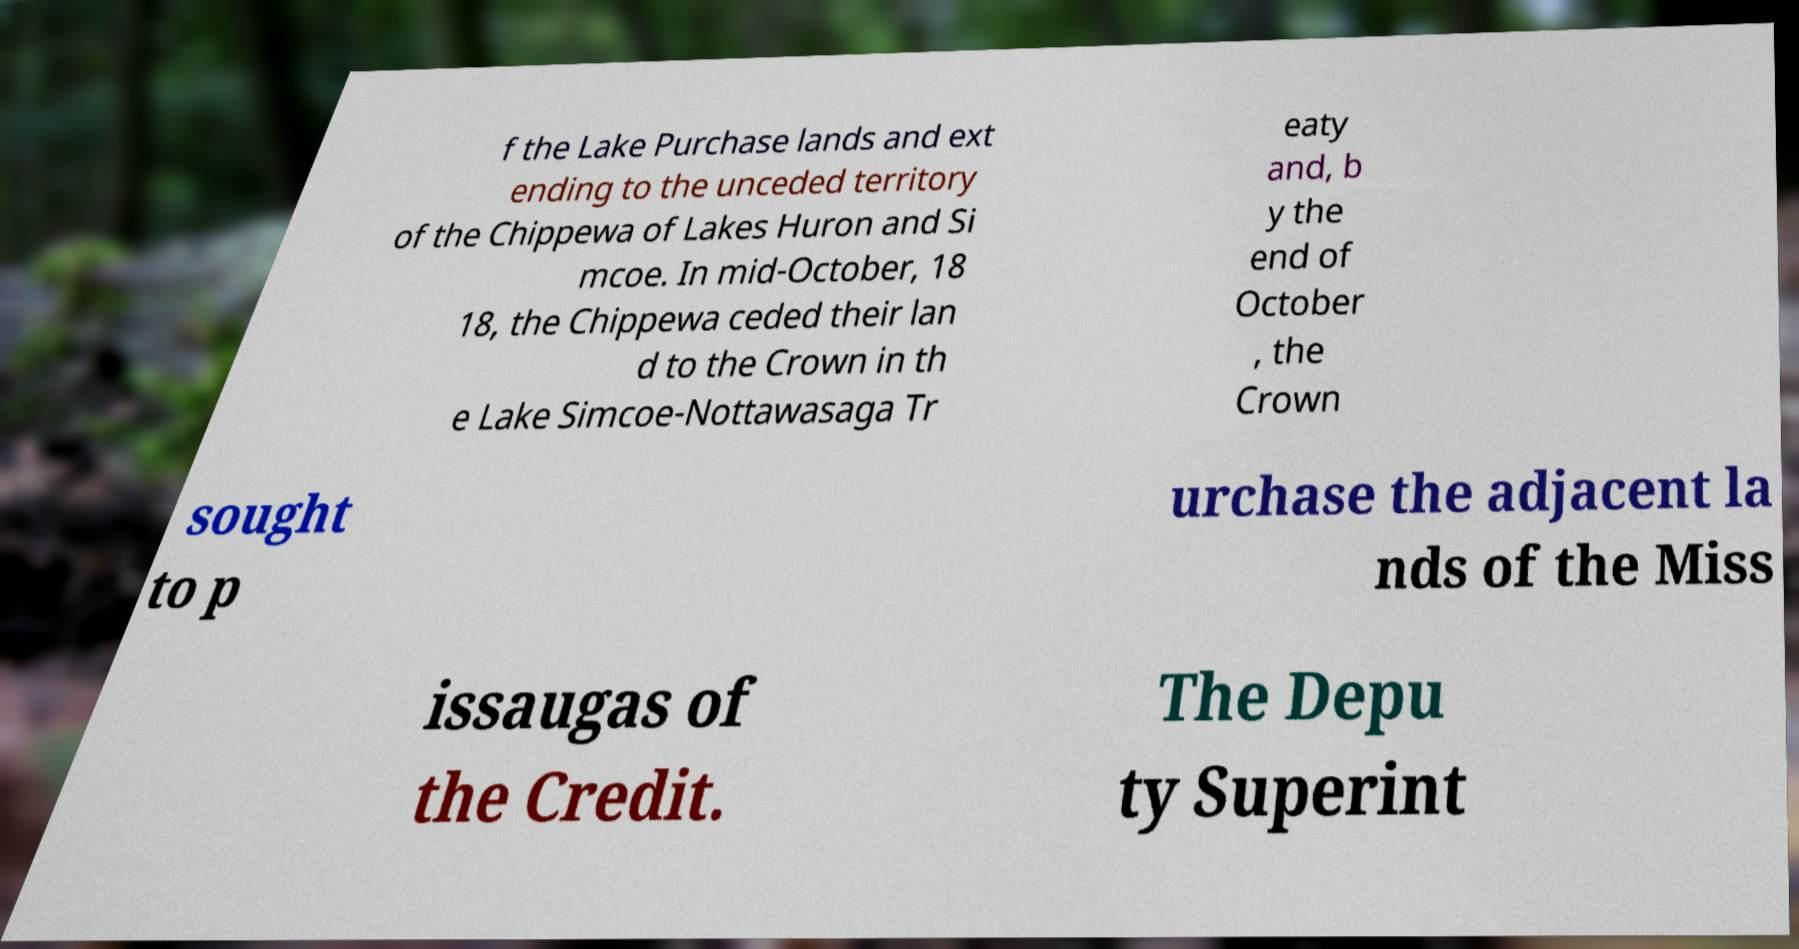Can you read and provide the text displayed in the image?This photo seems to have some interesting text. Can you extract and type it out for me? f the Lake Purchase lands and ext ending to the unceded territory of the Chippewa of Lakes Huron and Si mcoe. In mid-October, 18 18, the Chippewa ceded their lan d to the Crown in th e Lake Simcoe-Nottawasaga Tr eaty and, b y the end of October , the Crown sought to p urchase the adjacent la nds of the Miss issaugas of the Credit. The Depu ty Superint 